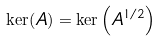Convert formula to latex. <formula><loc_0><loc_0><loc_500><loc_500>\ker ( A ) = \ker \left ( A ^ { 1 / 2 } \right )</formula> 